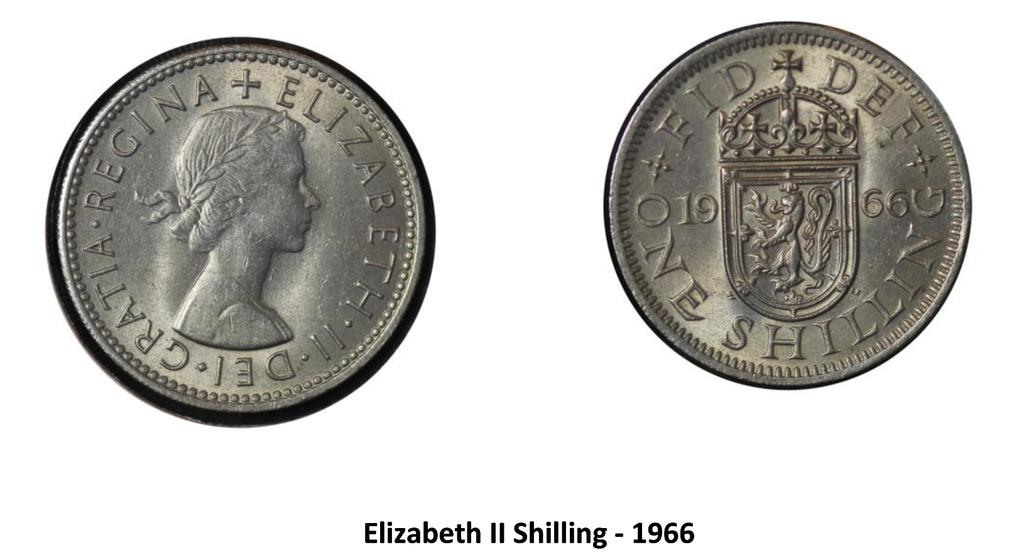<image>
Relay a brief, clear account of the picture shown. A coin that says Elizabeth II Shilling - 1966. 